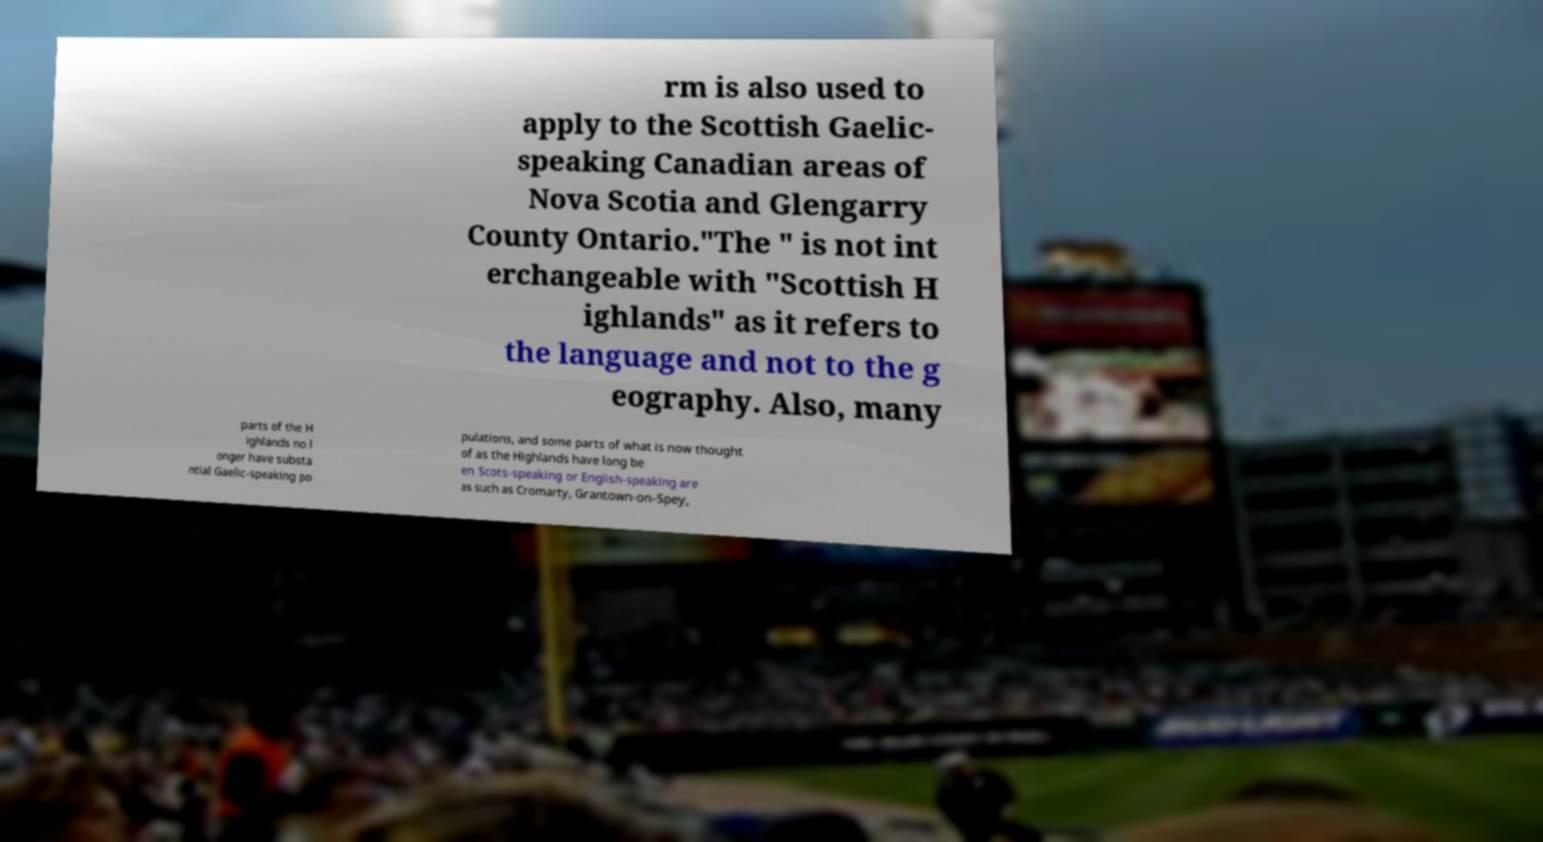Can you accurately transcribe the text from the provided image for me? rm is also used to apply to the Scottish Gaelic- speaking Canadian areas of Nova Scotia and Glengarry County Ontario."The " is not int erchangeable with "Scottish H ighlands" as it refers to the language and not to the g eography. Also, many parts of the H ighlands no l onger have substa ntial Gaelic-speaking po pulations, and some parts of what is now thought of as the Highlands have long be en Scots-speaking or English-speaking are as such as Cromarty, Grantown-on-Spey, 